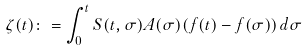<formula> <loc_0><loc_0><loc_500><loc_500>\zeta ( t ) \colon = \int _ { 0 } ^ { t } S ( t , \sigma ) A ( \sigma ) ( f ( t ) - f ( \sigma ) ) \, d \sigma</formula> 